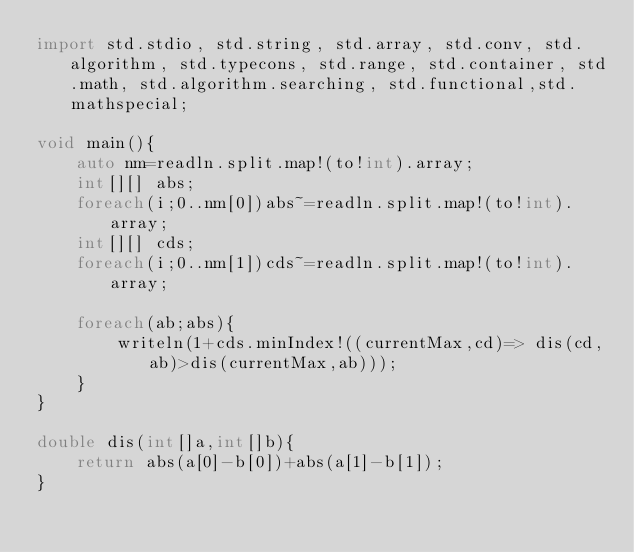<code> <loc_0><loc_0><loc_500><loc_500><_D_>import std.stdio, std.string, std.array, std.conv, std.algorithm, std.typecons, std.range, std.container, std.math, std.algorithm.searching, std.functional,std.mathspecial;

void main(){
    auto nm=readln.split.map!(to!int).array;
    int[][] abs;
    foreach(i;0..nm[0])abs~=readln.split.map!(to!int).array;
    int[][] cds;
    foreach(i;0..nm[1])cds~=readln.split.map!(to!int).array;

    foreach(ab;abs){
        writeln(1+cds.minIndex!((currentMax,cd)=> dis(cd,ab)>dis(currentMax,ab)));
    }
}

double dis(int[]a,int[]b){
    return abs(a[0]-b[0])+abs(a[1]-b[1]);
}
</code> 